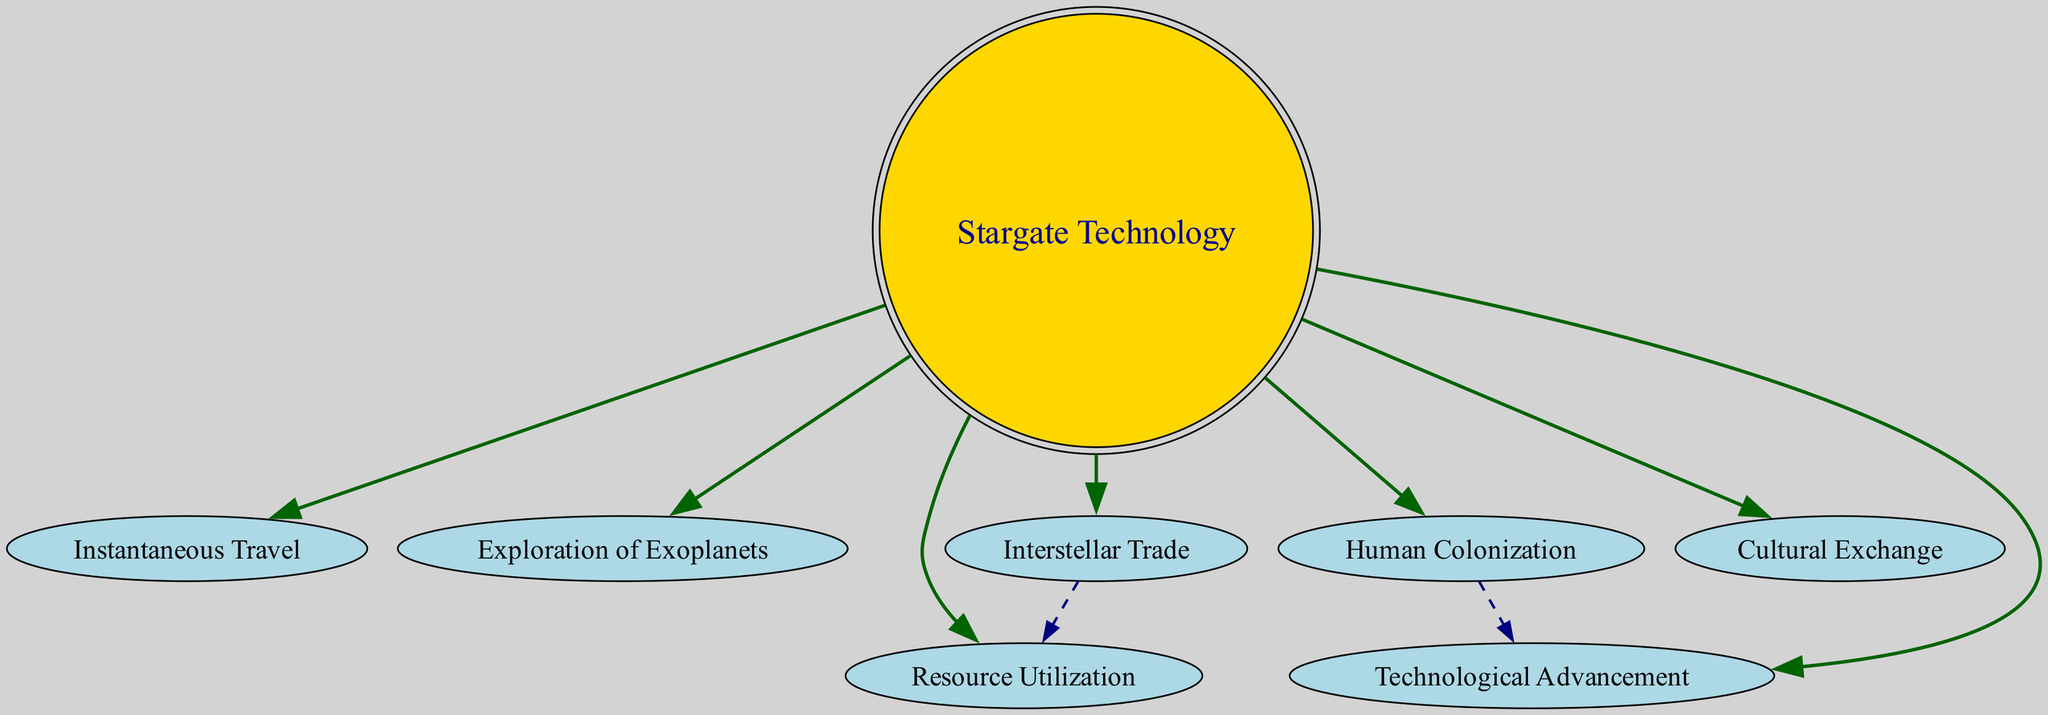What is the main concept represented in the diagram? The main concept or node at the center of the diagram is labeled "Stargate Technology," which is the foundational idea from which all other applications and implications flow.
Answer: Stargate Technology How many edges are connected to "Stargate Technology"? By counting the arrows (edges) that point away from the "Stargate Technology" node, we find there are 7 edges connecting it to other nodes.
Answer: 7 Which node is directly connected to "Human Colonization"? A single edge extends from "Human Colonization" to "Technological Advancement," indicating that it is the node that the former directly points to.
Answer: Technological Advancement What relationship exists between "Interstellar Trade" and "Resource Utilization"? The edge goes from "Interstellar Trade" to "Resource Utilization," indicating that interstellar trade influences how resources are utilized. This is depicted as a dashed line, suggesting a secondary or indirect relationship.
Answer: Interstellar Trade influences Resource Utilization How many total nodes are in the diagram? By reviewing the list of nodes, we can count a total of 8 distinct nodes present in the diagram.
Answer: 8 What type of relationship connects "Stargate Technology" to "Instantaneous Travel"? The relationship is direct, as shown by the solid edge connecting the two nodes, indicating a strong direct implication of one on the other.
Answer: Direct relationship Which approach does "Stargate Technology" indicate for space colonization? The diagram shows that "Stargate Technology" leads to "Human Colonization," suggesting it plays a crucial role in enabling human colonization efforts in space.
Answer: Human Colonization What does the arrow from "Human Colonization" to "Technological Advancement" imply? This arrow implies that advancements in technology may result from or be influenced by the process of colonizing new human habitats in space.
Answer: Technological Advancement is influenced by Human Colonization 